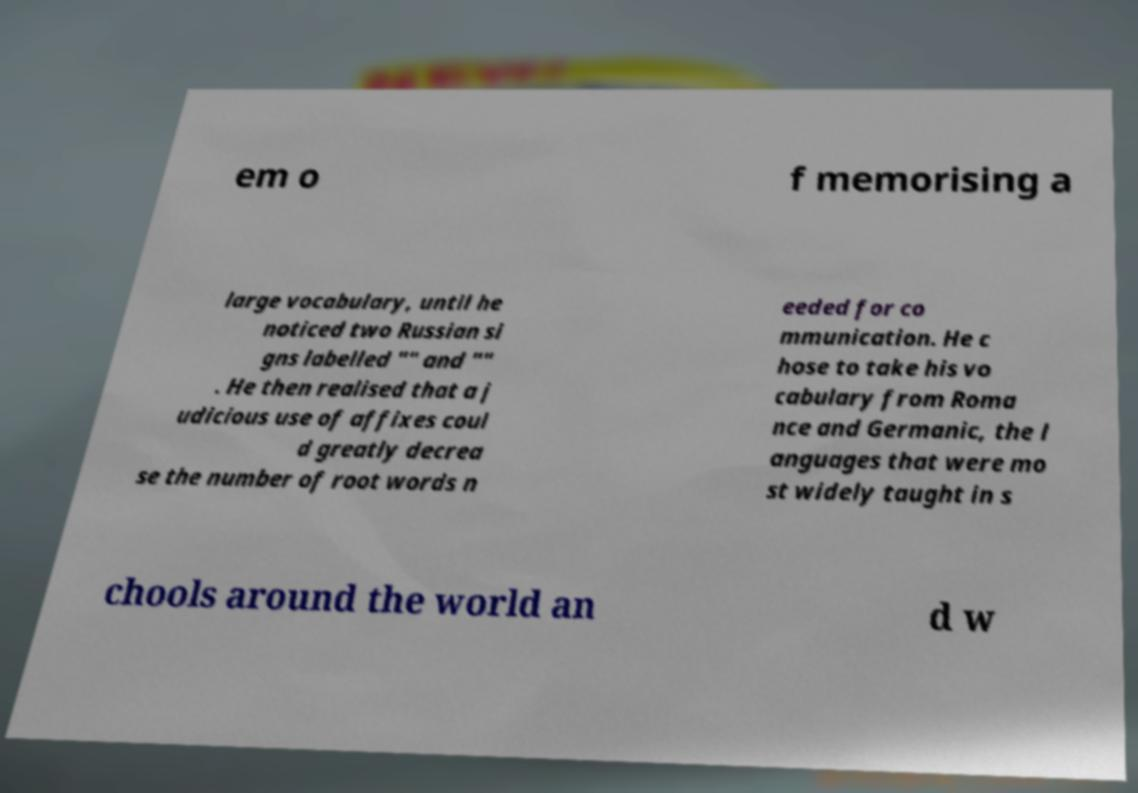For documentation purposes, I need the text within this image transcribed. Could you provide that? em o f memorising a large vocabulary, until he noticed two Russian si gns labelled "" and "" . He then realised that a j udicious use of affixes coul d greatly decrea se the number of root words n eeded for co mmunication. He c hose to take his vo cabulary from Roma nce and Germanic, the l anguages that were mo st widely taught in s chools around the world an d w 